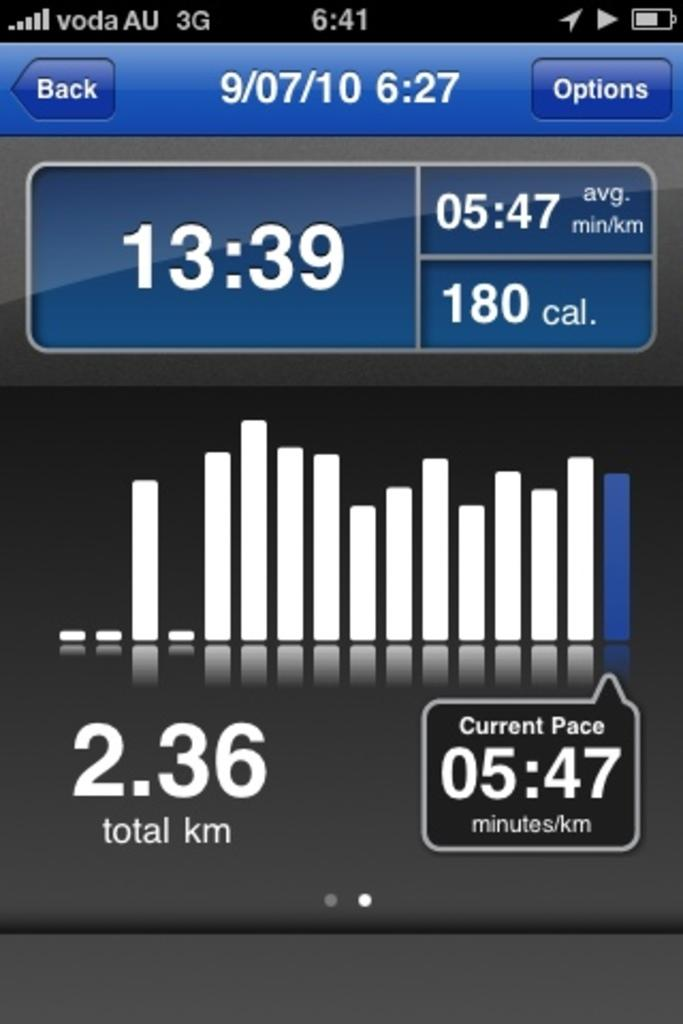<image>
Relay a brief, clear account of the picture shown. A smartphone screen shows that the time is 6:27 in 2010. 